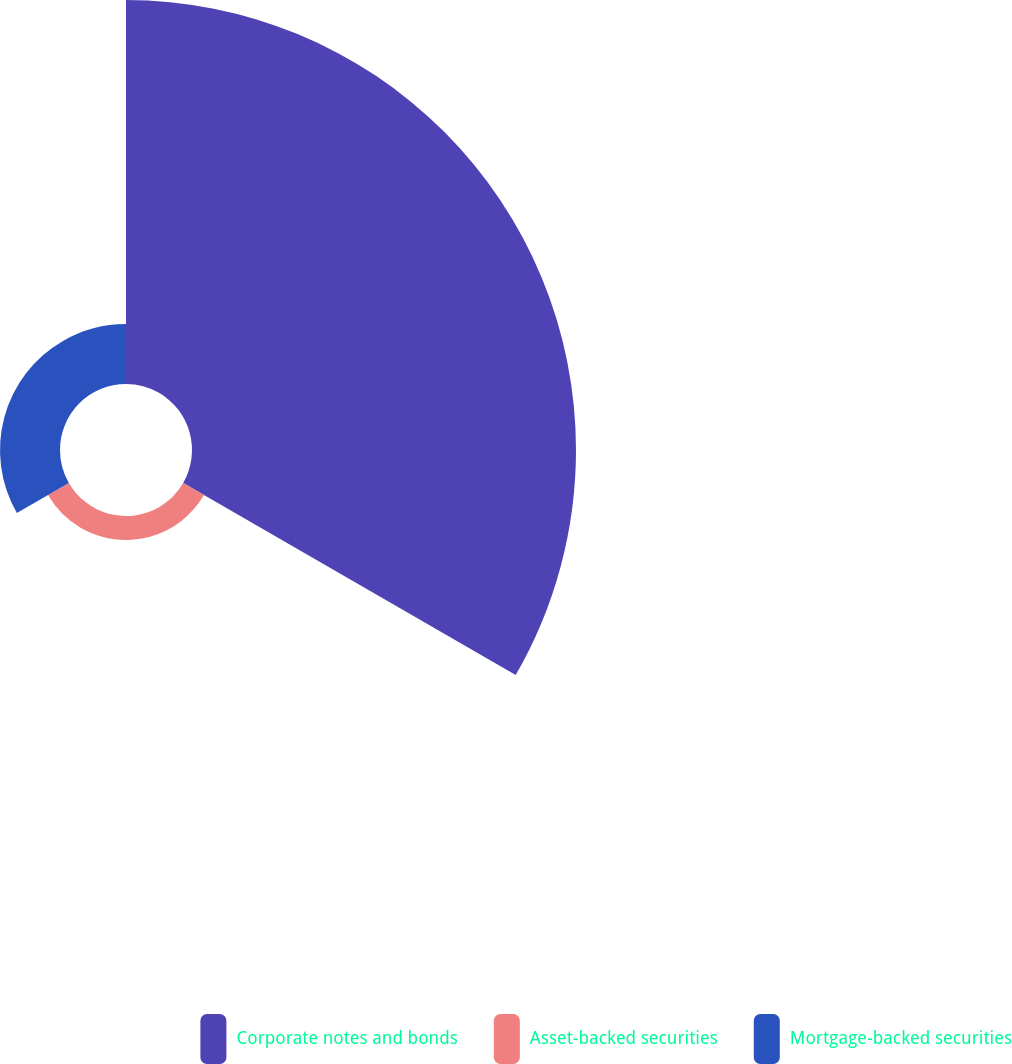Convert chart to OTSL. <chart><loc_0><loc_0><loc_500><loc_500><pie_chart><fcel>Corporate notes and bonds<fcel>Asset-backed securities<fcel>Mortgage-backed securities<nl><fcel>82.05%<fcel>5.13%<fcel>12.82%<nl></chart> 